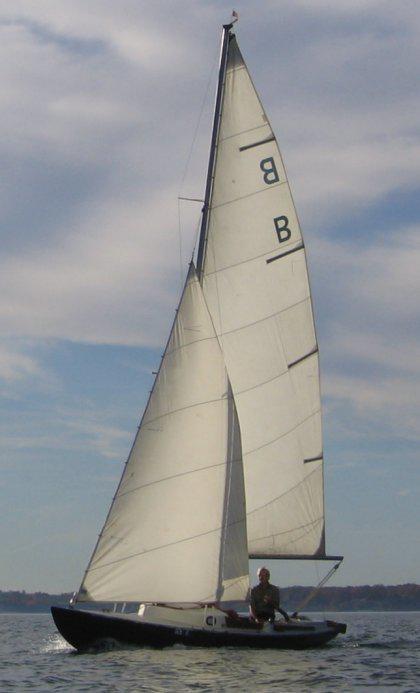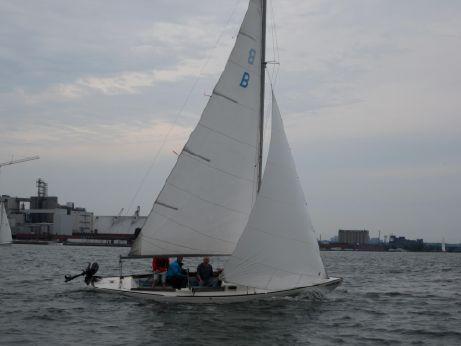The first image is the image on the left, the second image is the image on the right. For the images displayed, is the sentence "At least one of the boats has a white hull." factually correct? Answer yes or no. Yes. The first image is the image on the left, the second image is the image on the right. Evaluate the accuracy of this statement regarding the images: "In one of the images there is a lone person sailing a boat in the center of the image.". Is it true? Answer yes or no. Yes. 